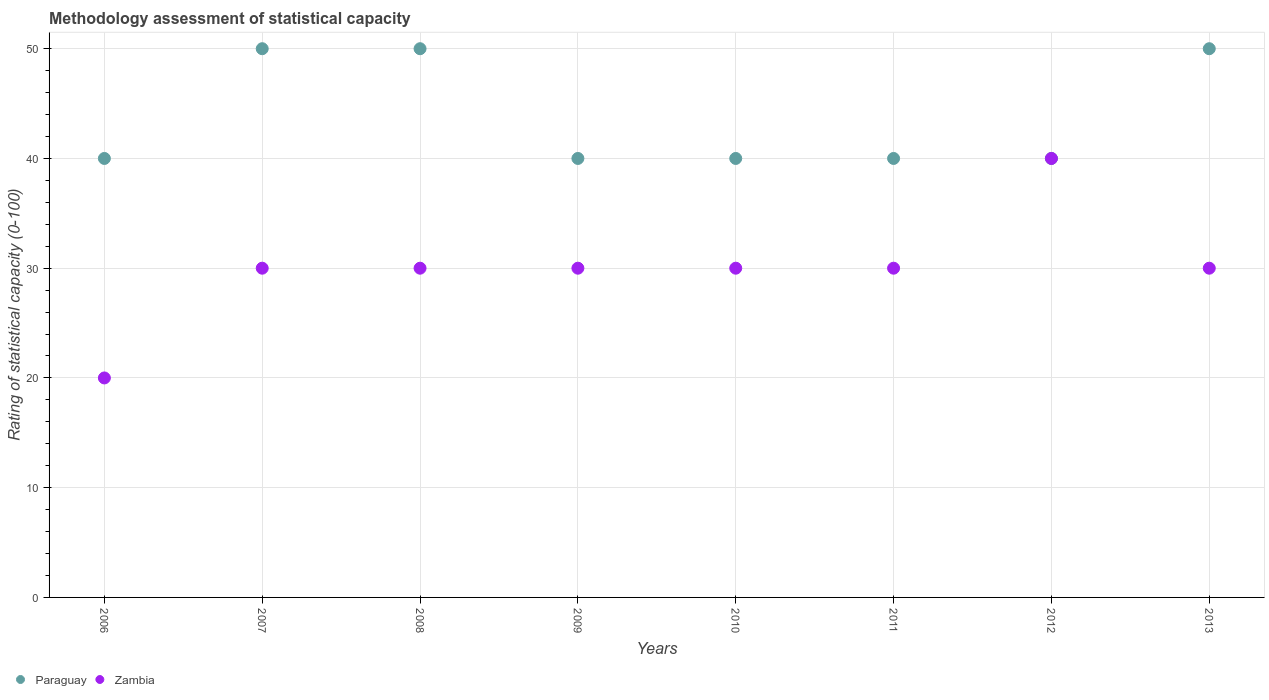What is the rating of statistical capacity in Paraguay in 2006?
Ensure brevity in your answer.  40. Across all years, what is the maximum rating of statistical capacity in Zambia?
Make the answer very short. 40. Across all years, what is the minimum rating of statistical capacity in Paraguay?
Offer a very short reply. 40. In which year was the rating of statistical capacity in Zambia minimum?
Offer a very short reply. 2006. What is the total rating of statistical capacity in Paraguay in the graph?
Give a very brief answer. 350. What is the difference between the rating of statistical capacity in Zambia in 2006 and that in 2008?
Give a very brief answer. -10. What is the difference between the rating of statistical capacity in Paraguay in 2006 and the rating of statistical capacity in Zambia in 2008?
Provide a succinct answer. 10. What is the average rating of statistical capacity in Zambia per year?
Keep it short and to the point. 30. In how many years, is the rating of statistical capacity in Paraguay greater than 28?
Ensure brevity in your answer.  8. What is the ratio of the rating of statistical capacity in Paraguay in 2006 to that in 2010?
Your answer should be very brief. 1. Is the difference between the rating of statistical capacity in Zambia in 2009 and 2013 greater than the difference between the rating of statistical capacity in Paraguay in 2009 and 2013?
Ensure brevity in your answer.  Yes. What is the difference between the highest and the lowest rating of statistical capacity in Paraguay?
Offer a very short reply. 10. In how many years, is the rating of statistical capacity in Paraguay greater than the average rating of statistical capacity in Paraguay taken over all years?
Your response must be concise. 3. Is the rating of statistical capacity in Zambia strictly less than the rating of statistical capacity in Paraguay over the years?
Provide a short and direct response. No. Does the graph contain grids?
Offer a very short reply. Yes. What is the title of the graph?
Make the answer very short. Methodology assessment of statistical capacity. Does "Thailand" appear as one of the legend labels in the graph?
Keep it short and to the point. No. What is the label or title of the Y-axis?
Give a very brief answer. Rating of statistical capacity (0-100). What is the Rating of statistical capacity (0-100) of Paraguay in 2007?
Ensure brevity in your answer.  50. What is the Rating of statistical capacity (0-100) of Paraguay in 2008?
Offer a very short reply. 50. What is the Rating of statistical capacity (0-100) of Zambia in 2008?
Keep it short and to the point. 30. What is the Rating of statistical capacity (0-100) of Paraguay in 2009?
Make the answer very short. 40. What is the Rating of statistical capacity (0-100) of Paraguay in 2011?
Your answer should be compact. 40. What is the Rating of statistical capacity (0-100) of Zambia in 2012?
Provide a short and direct response. 40. What is the Rating of statistical capacity (0-100) of Paraguay in 2013?
Give a very brief answer. 50. What is the Rating of statistical capacity (0-100) in Zambia in 2013?
Offer a terse response. 30. Across all years, what is the maximum Rating of statistical capacity (0-100) in Zambia?
Provide a succinct answer. 40. Across all years, what is the minimum Rating of statistical capacity (0-100) in Zambia?
Provide a succinct answer. 20. What is the total Rating of statistical capacity (0-100) of Paraguay in the graph?
Give a very brief answer. 350. What is the total Rating of statistical capacity (0-100) in Zambia in the graph?
Provide a succinct answer. 240. What is the difference between the Rating of statistical capacity (0-100) in Paraguay in 2006 and that in 2007?
Provide a succinct answer. -10. What is the difference between the Rating of statistical capacity (0-100) of Zambia in 2006 and that in 2007?
Make the answer very short. -10. What is the difference between the Rating of statistical capacity (0-100) in Paraguay in 2006 and that in 2008?
Provide a short and direct response. -10. What is the difference between the Rating of statistical capacity (0-100) in Zambia in 2006 and that in 2008?
Offer a terse response. -10. What is the difference between the Rating of statistical capacity (0-100) of Paraguay in 2006 and that in 2009?
Give a very brief answer. 0. What is the difference between the Rating of statistical capacity (0-100) of Zambia in 2006 and that in 2009?
Give a very brief answer. -10. What is the difference between the Rating of statistical capacity (0-100) in Zambia in 2006 and that in 2010?
Give a very brief answer. -10. What is the difference between the Rating of statistical capacity (0-100) of Paraguay in 2006 and that in 2011?
Your answer should be very brief. 0. What is the difference between the Rating of statistical capacity (0-100) in Zambia in 2006 and that in 2011?
Keep it short and to the point. -10. What is the difference between the Rating of statistical capacity (0-100) in Zambia in 2006 and that in 2012?
Offer a very short reply. -20. What is the difference between the Rating of statistical capacity (0-100) of Zambia in 2007 and that in 2008?
Give a very brief answer. 0. What is the difference between the Rating of statistical capacity (0-100) of Paraguay in 2007 and that in 2009?
Provide a succinct answer. 10. What is the difference between the Rating of statistical capacity (0-100) of Paraguay in 2007 and that in 2010?
Make the answer very short. 10. What is the difference between the Rating of statistical capacity (0-100) of Zambia in 2007 and that in 2011?
Ensure brevity in your answer.  0. What is the difference between the Rating of statistical capacity (0-100) in Paraguay in 2007 and that in 2012?
Your answer should be compact. 10. What is the difference between the Rating of statistical capacity (0-100) of Zambia in 2007 and that in 2013?
Ensure brevity in your answer.  0. What is the difference between the Rating of statistical capacity (0-100) of Zambia in 2008 and that in 2010?
Provide a short and direct response. 0. What is the difference between the Rating of statistical capacity (0-100) of Zambia in 2008 and that in 2013?
Give a very brief answer. 0. What is the difference between the Rating of statistical capacity (0-100) of Paraguay in 2009 and that in 2010?
Provide a short and direct response. 0. What is the difference between the Rating of statistical capacity (0-100) in Paraguay in 2009 and that in 2011?
Your response must be concise. 0. What is the difference between the Rating of statistical capacity (0-100) of Paraguay in 2009 and that in 2012?
Your answer should be compact. 0. What is the difference between the Rating of statistical capacity (0-100) of Zambia in 2010 and that in 2011?
Make the answer very short. 0. What is the difference between the Rating of statistical capacity (0-100) in Paraguay in 2010 and that in 2013?
Your answer should be very brief. -10. What is the difference between the Rating of statistical capacity (0-100) of Zambia in 2010 and that in 2013?
Make the answer very short. 0. What is the difference between the Rating of statistical capacity (0-100) in Zambia in 2011 and that in 2012?
Ensure brevity in your answer.  -10. What is the difference between the Rating of statistical capacity (0-100) of Paraguay in 2011 and that in 2013?
Offer a terse response. -10. What is the difference between the Rating of statistical capacity (0-100) in Zambia in 2011 and that in 2013?
Provide a short and direct response. 0. What is the difference between the Rating of statistical capacity (0-100) of Paraguay in 2012 and that in 2013?
Offer a terse response. -10. What is the difference between the Rating of statistical capacity (0-100) of Zambia in 2012 and that in 2013?
Make the answer very short. 10. What is the difference between the Rating of statistical capacity (0-100) in Paraguay in 2006 and the Rating of statistical capacity (0-100) in Zambia in 2007?
Provide a succinct answer. 10. What is the difference between the Rating of statistical capacity (0-100) in Paraguay in 2006 and the Rating of statistical capacity (0-100) in Zambia in 2008?
Provide a short and direct response. 10. What is the difference between the Rating of statistical capacity (0-100) in Paraguay in 2006 and the Rating of statistical capacity (0-100) in Zambia in 2011?
Give a very brief answer. 10. What is the difference between the Rating of statistical capacity (0-100) of Paraguay in 2007 and the Rating of statistical capacity (0-100) of Zambia in 2008?
Offer a terse response. 20. What is the difference between the Rating of statistical capacity (0-100) of Paraguay in 2008 and the Rating of statistical capacity (0-100) of Zambia in 2011?
Make the answer very short. 20. What is the difference between the Rating of statistical capacity (0-100) in Paraguay in 2008 and the Rating of statistical capacity (0-100) in Zambia in 2012?
Your answer should be very brief. 10. What is the difference between the Rating of statistical capacity (0-100) in Paraguay in 2008 and the Rating of statistical capacity (0-100) in Zambia in 2013?
Your response must be concise. 20. What is the difference between the Rating of statistical capacity (0-100) in Paraguay in 2009 and the Rating of statistical capacity (0-100) in Zambia in 2011?
Give a very brief answer. 10. What is the difference between the Rating of statistical capacity (0-100) in Paraguay in 2009 and the Rating of statistical capacity (0-100) in Zambia in 2013?
Your response must be concise. 10. What is the difference between the Rating of statistical capacity (0-100) in Paraguay in 2010 and the Rating of statistical capacity (0-100) in Zambia in 2012?
Offer a terse response. 0. What is the average Rating of statistical capacity (0-100) of Paraguay per year?
Offer a terse response. 43.75. In the year 2011, what is the difference between the Rating of statistical capacity (0-100) of Paraguay and Rating of statistical capacity (0-100) of Zambia?
Your answer should be compact. 10. What is the ratio of the Rating of statistical capacity (0-100) of Zambia in 2006 to that in 2007?
Provide a short and direct response. 0.67. What is the ratio of the Rating of statistical capacity (0-100) of Paraguay in 2006 to that in 2008?
Keep it short and to the point. 0.8. What is the ratio of the Rating of statistical capacity (0-100) in Paraguay in 2006 to that in 2009?
Your response must be concise. 1. What is the ratio of the Rating of statistical capacity (0-100) of Zambia in 2006 to that in 2009?
Offer a terse response. 0.67. What is the ratio of the Rating of statistical capacity (0-100) in Paraguay in 2006 to that in 2010?
Provide a short and direct response. 1. What is the ratio of the Rating of statistical capacity (0-100) of Paraguay in 2006 to that in 2011?
Offer a terse response. 1. What is the ratio of the Rating of statistical capacity (0-100) of Zambia in 2006 to that in 2011?
Keep it short and to the point. 0.67. What is the ratio of the Rating of statistical capacity (0-100) of Paraguay in 2006 to that in 2012?
Give a very brief answer. 1. What is the ratio of the Rating of statistical capacity (0-100) in Zambia in 2006 to that in 2012?
Keep it short and to the point. 0.5. What is the ratio of the Rating of statistical capacity (0-100) in Zambia in 2006 to that in 2013?
Make the answer very short. 0.67. What is the ratio of the Rating of statistical capacity (0-100) in Paraguay in 2007 to that in 2008?
Provide a succinct answer. 1. What is the ratio of the Rating of statistical capacity (0-100) in Zambia in 2007 to that in 2008?
Your response must be concise. 1. What is the ratio of the Rating of statistical capacity (0-100) of Paraguay in 2007 to that in 2009?
Ensure brevity in your answer.  1.25. What is the ratio of the Rating of statistical capacity (0-100) in Paraguay in 2007 to that in 2011?
Keep it short and to the point. 1.25. What is the ratio of the Rating of statistical capacity (0-100) of Zambia in 2007 to that in 2012?
Offer a very short reply. 0.75. What is the ratio of the Rating of statistical capacity (0-100) in Zambia in 2008 to that in 2009?
Offer a terse response. 1. What is the ratio of the Rating of statistical capacity (0-100) of Paraguay in 2008 to that in 2010?
Ensure brevity in your answer.  1.25. What is the ratio of the Rating of statistical capacity (0-100) in Zambia in 2008 to that in 2010?
Offer a terse response. 1. What is the ratio of the Rating of statistical capacity (0-100) of Zambia in 2008 to that in 2011?
Your answer should be very brief. 1. What is the ratio of the Rating of statistical capacity (0-100) of Paraguay in 2008 to that in 2012?
Your answer should be compact. 1.25. What is the ratio of the Rating of statistical capacity (0-100) in Zambia in 2008 to that in 2012?
Ensure brevity in your answer.  0.75. What is the ratio of the Rating of statistical capacity (0-100) of Zambia in 2008 to that in 2013?
Provide a succinct answer. 1. What is the ratio of the Rating of statistical capacity (0-100) in Paraguay in 2009 to that in 2010?
Ensure brevity in your answer.  1. What is the ratio of the Rating of statistical capacity (0-100) of Paraguay in 2009 to that in 2011?
Make the answer very short. 1. What is the ratio of the Rating of statistical capacity (0-100) in Zambia in 2009 to that in 2011?
Provide a short and direct response. 1. What is the ratio of the Rating of statistical capacity (0-100) in Paraguay in 2010 to that in 2011?
Ensure brevity in your answer.  1. What is the ratio of the Rating of statistical capacity (0-100) of Zambia in 2010 to that in 2011?
Your answer should be very brief. 1. What is the ratio of the Rating of statistical capacity (0-100) in Paraguay in 2010 to that in 2012?
Ensure brevity in your answer.  1. What is the ratio of the Rating of statistical capacity (0-100) in Paraguay in 2011 to that in 2012?
Your answer should be very brief. 1. What is the ratio of the Rating of statistical capacity (0-100) of Zambia in 2011 to that in 2012?
Ensure brevity in your answer.  0.75. What is the ratio of the Rating of statistical capacity (0-100) of Paraguay in 2011 to that in 2013?
Offer a terse response. 0.8. What is the ratio of the Rating of statistical capacity (0-100) in Zambia in 2012 to that in 2013?
Keep it short and to the point. 1.33. What is the difference between the highest and the second highest Rating of statistical capacity (0-100) of Zambia?
Your answer should be compact. 10. What is the difference between the highest and the lowest Rating of statistical capacity (0-100) in Paraguay?
Your answer should be very brief. 10. 